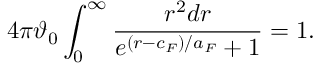<formula> <loc_0><loc_0><loc_500><loc_500>4 \pi \vartheta _ { 0 } \int _ { 0 } ^ { \infty } \frac { r ^ { 2 } d r } { e ^ { ( r - c _ { F } ) / a _ { F } } + 1 } = 1 .</formula> 